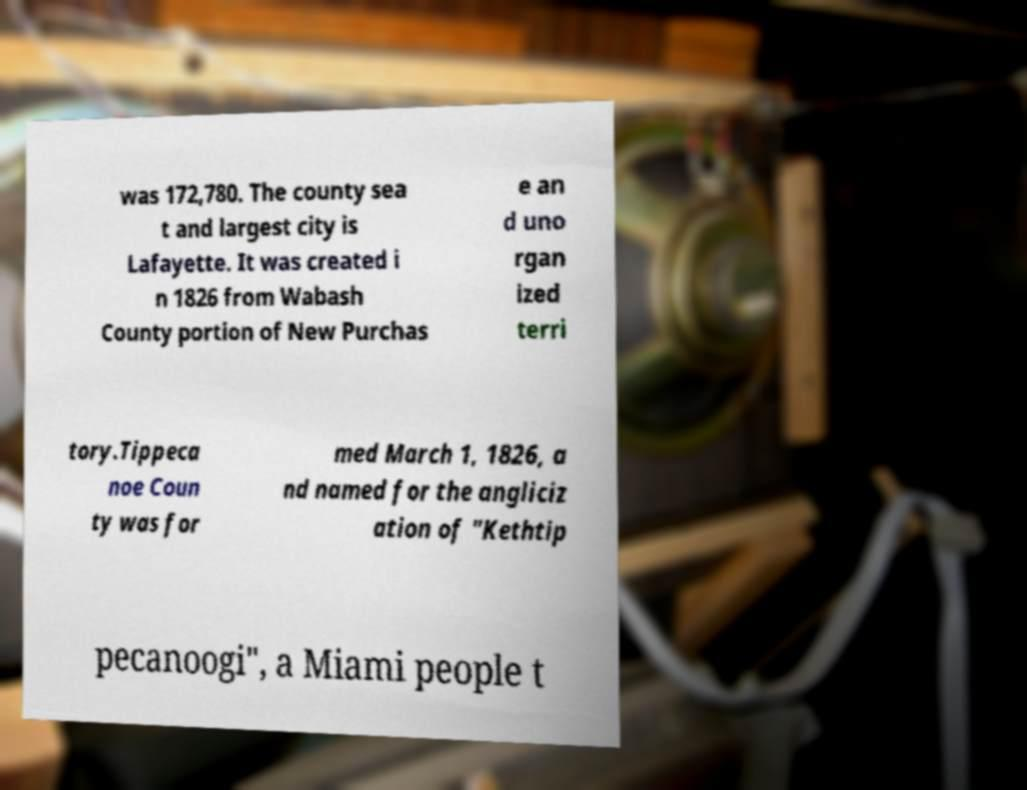Please read and relay the text visible in this image. What does it say? was 172,780. The county sea t and largest city is Lafayette. It was created i n 1826 from Wabash County portion of New Purchas e an d uno rgan ized terri tory.Tippeca noe Coun ty was for med March 1, 1826, a nd named for the angliciz ation of "Kethtip pecanoogi", a Miami people t 